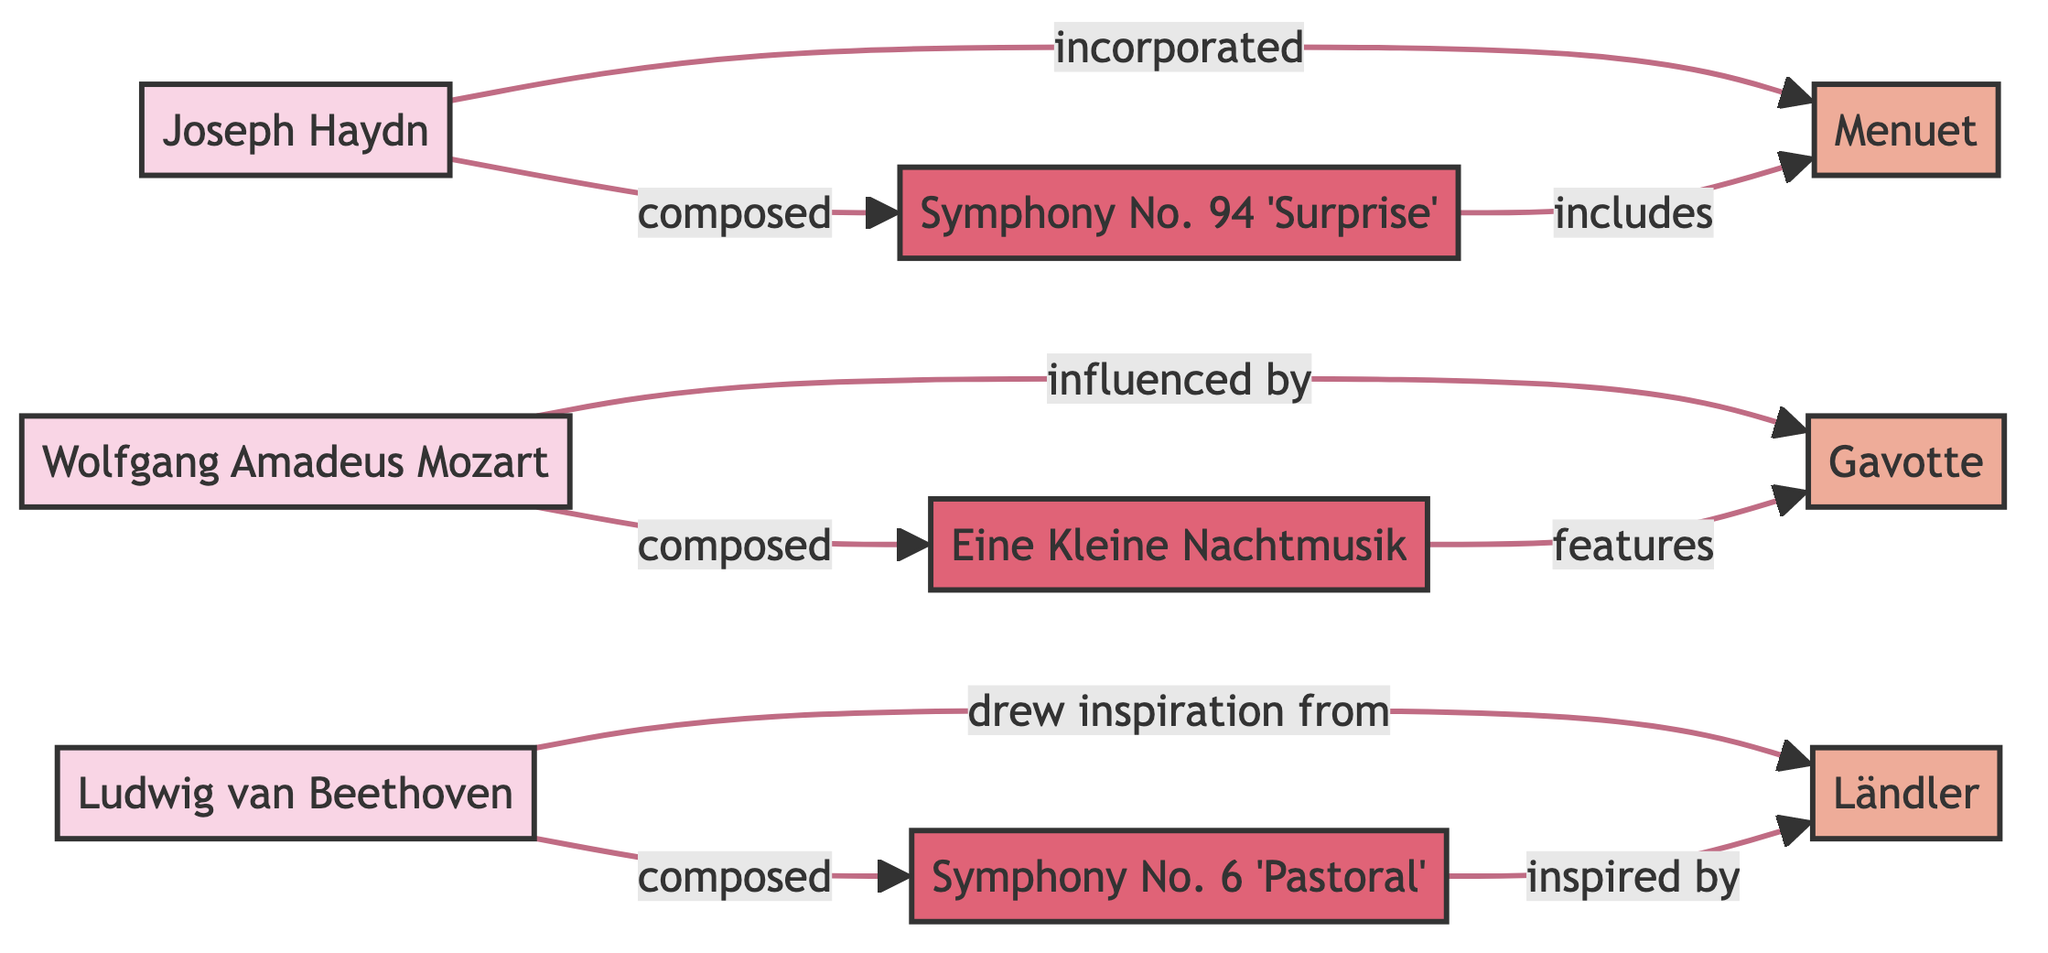What are the three composers represented in the diagram? The diagram includes three composers: Joseph Haydn, Wolfgang Amadeus Mozart, and Ludwig van Beethoven. These names are listed as nodes without any additional names attached.
Answer: Joseph Haydn, Wolfgang Amadeus Mozart, Ludwig van Beethoven How many edges are present in the diagram? By counting the lines connecting the nodes, I can see there are eight edges connecting the three composers to their corresponding folk dances and compositions.
Answer: 8 Which dance does Haydn's Symphony No. 94 include? Following the arrow from Symphony No. 94 to its connected node, the diagram indicates that this composition includes the Menuet dance.
Answer: Menuet What relationship does Beethoven have with Ländler? The diagram shows an edge from Beethoven to Ländler with the relationship labeled as "drew inspiration from," indicating that Beethoven drew inspiration from this dance.
Answer: drew inspiration from Which composer composed Eine Kleine Nachtmusik? Tracing the edge leading from Mozart to the node for Eine Kleine Nachtmusik shows that Mozart is the composer of this piece.
Answer: Mozart Which dance is influenced by Mozart’s work? Looking at the connection from Mozart to the Gavotte in the diagram, it's clear that the Gavotte dance is influenced by Mozart.
Answer: Gavotte How are Menuet and Haydn related? The arrow from Haydn to Menuet indicates that Haydn incorporated the Menuet dance into his compositions, showing a direct relationship where the influence flows from Haydn to Menuet.
Answer: incorporated Which composition is inspired by folk traditions according to the diagram? Checking the edge from Beethoven, I can see that Symphony No. 6 is the composition connected to Ländler, indicated as "inspired by." This shows that it is inspired by folk traditions.
Answer: Symphony No. 6 'Pastoral' 